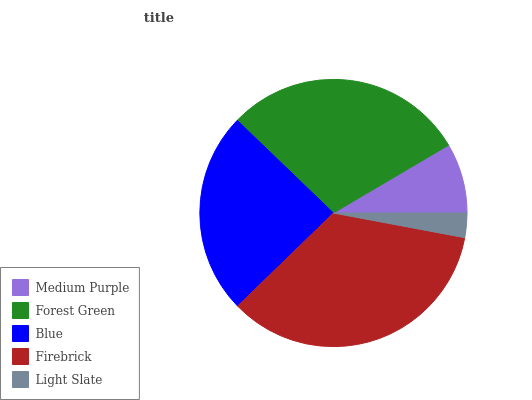Is Light Slate the minimum?
Answer yes or no. Yes. Is Firebrick the maximum?
Answer yes or no. Yes. Is Forest Green the minimum?
Answer yes or no. No. Is Forest Green the maximum?
Answer yes or no. No. Is Forest Green greater than Medium Purple?
Answer yes or no. Yes. Is Medium Purple less than Forest Green?
Answer yes or no. Yes. Is Medium Purple greater than Forest Green?
Answer yes or no. No. Is Forest Green less than Medium Purple?
Answer yes or no. No. Is Blue the high median?
Answer yes or no. Yes. Is Blue the low median?
Answer yes or no. Yes. Is Firebrick the high median?
Answer yes or no. No. Is Medium Purple the low median?
Answer yes or no. No. 